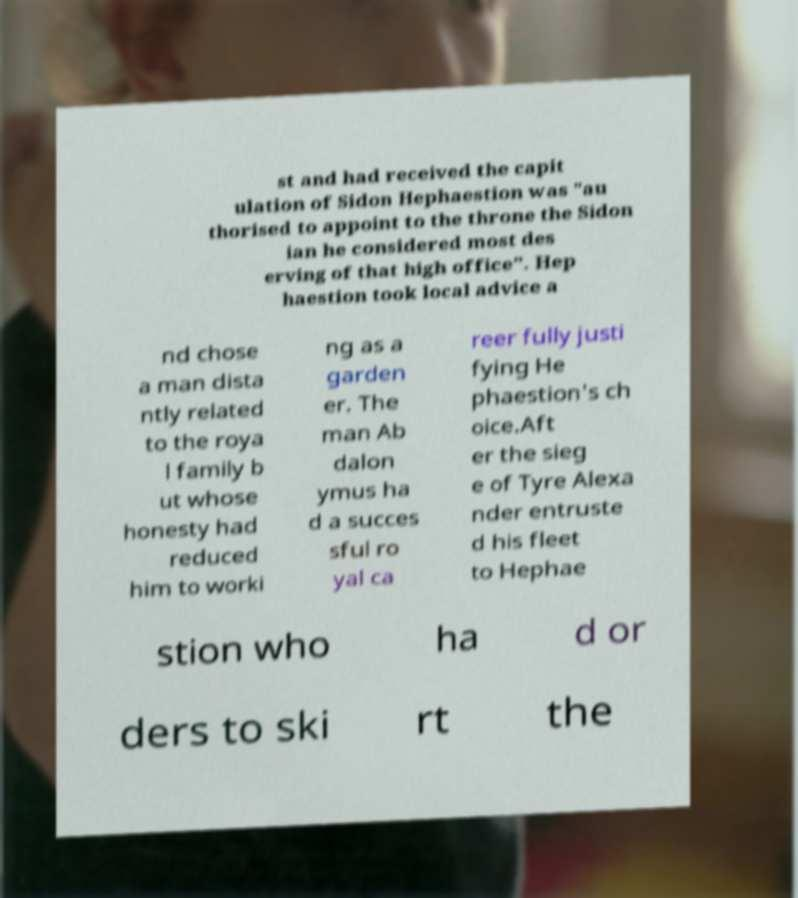What messages or text are displayed in this image? I need them in a readable, typed format. st and had received the capit ulation of Sidon Hephaestion was "au thorised to appoint to the throne the Sidon ian he considered most des erving of that high office". Hep haestion took local advice a nd chose a man dista ntly related to the roya l family b ut whose honesty had reduced him to worki ng as a garden er. The man Ab dalon ymus ha d a succes sful ro yal ca reer fully justi fying He phaestion's ch oice.Aft er the sieg e of Tyre Alexa nder entruste d his fleet to Hephae stion who ha d or ders to ski rt the 